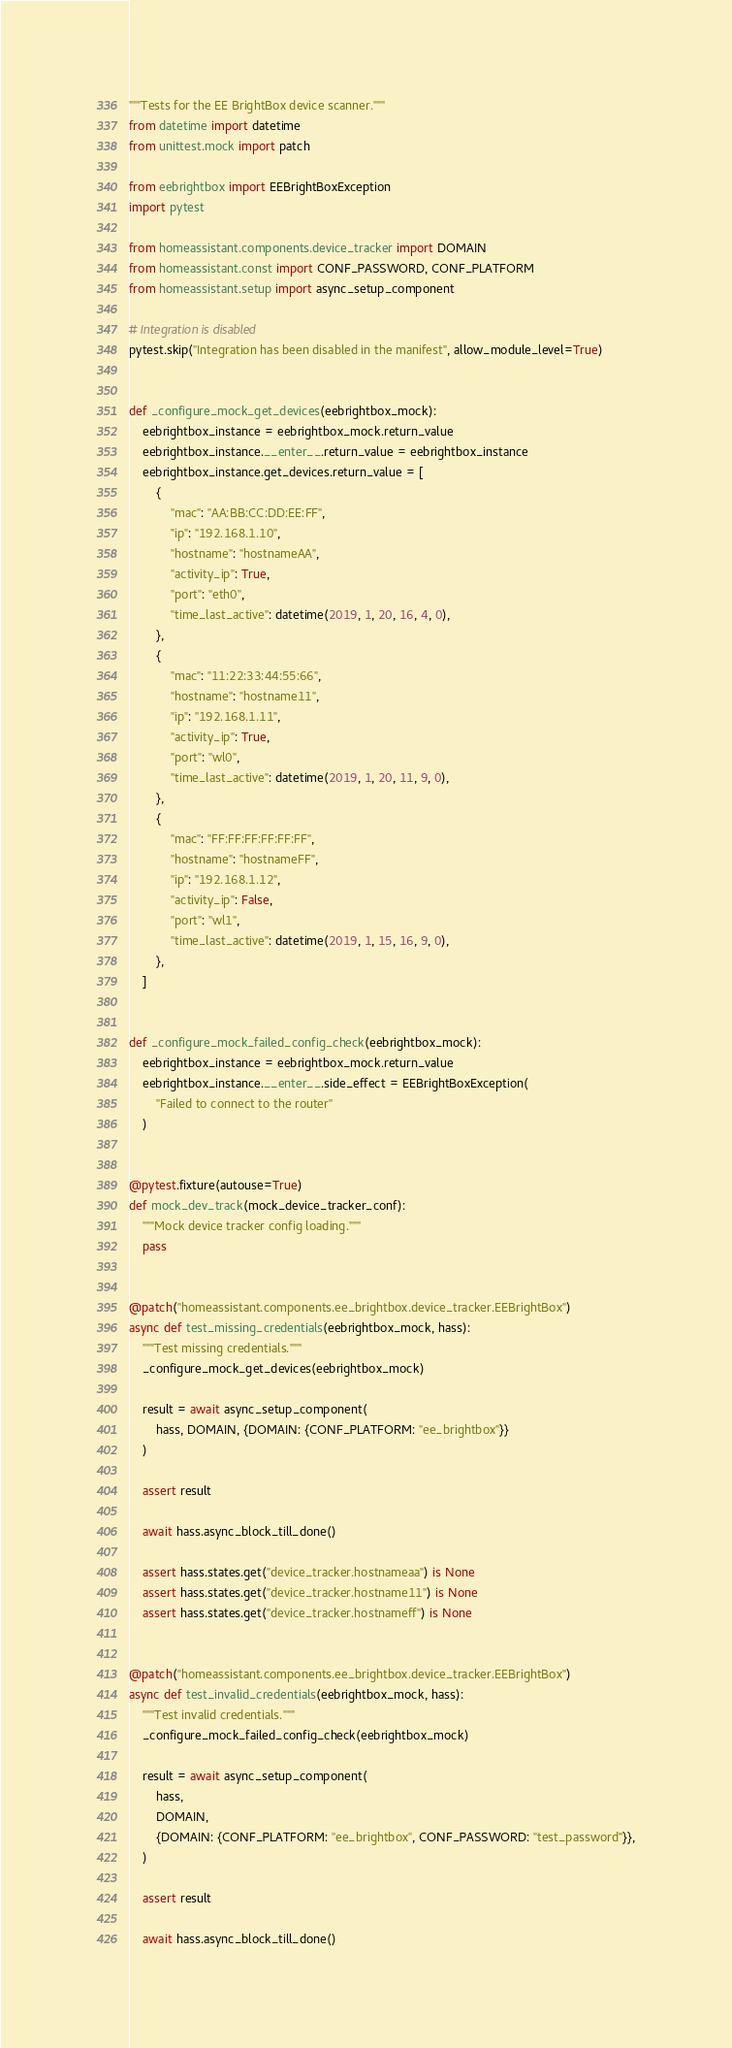Convert code to text. <code><loc_0><loc_0><loc_500><loc_500><_Python_>"""Tests for the EE BrightBox device scanner."""
from datetime import datetime
from unittest.mock import patch

from eebrightbox import EEBrightBoxException
import pytest

from homeassistant.components.device_tracker import DOMAIN
from homeassistant.const import CONF_PASSWORD, CONF_PLATFORM
from homeassistant.setup import async_setup_component

# Integration is disabled
pytest.skip("Integration has been disabled in the manifest", allow_module_level=True)


def _configure_mock_get_devices(eebrightbox_mock):
    eebrightbox_instance = eebrightbox_mock.return_value
    eebrightbox_instance.__enter__.return_value = eebrightbox_instance
    eebrightbox_instance.get_devices.return_value = [
        {
            "mac": "AA:BB:CC:DD:EE:FF",
            "ip": "192.168.1.10",
            "hostname": "hostnameAA",
            "activity_ip": True,
            "port": "eth0",
            "time_last_active": datetime(2019, 1, 20, 16, 4, 0),
        },
        {
            "mac": "11:22:33:44:55:66",
            "hostname": "hostname11",
            "ip": "192.168.1.11",
            "activity_ip": True,
            "port": "wl0",
            "time_last_active": datetime(2019, 1, 20, 11, 9, 0),
        },
        {
            "mac": "FF:FF:FF:FF:FF:FF",
            "hostname": "hostnameFF",
            "ip": "192.168.1.12",
            "activity_ip": False,
            "port": "wl1",
            "time_last_active": datetime(2019, 1, 15, 16, 9, 0),
        },
    ]


def _configure_mock_failed_config_check(eebrightbox_mock):
    eebrightbox_instance = eebrightbox_mock.return_value
    eebrightbox_instance.__enter__.side_effect = EEBrightBoxException(
        "Failed to connect to the router"
    )


@pytest.fixture(autouse=True)
def mock_dev_track(mock_device_tracker_conf):
    """Mock device tracker config loading."""
    pass


@patch("homeassistant.components.ee_brightbox.device_tracker.EEBrightBox")
async def test_missing_credentials(eebrightbox_mock, hass):
    """Test missing credentials."""
    _configure_mock_get_devices(eebrightbox_mock)

    result = await async_setup_component(
        hass, DOMAIN, {DOMAIN: {CONF_PLATFORM: "ee_brightbox"}}
    )

    assert result

    await hass.async_block_till_done()

    assert hass.states.get("device_tracker.hostnameaa") is None
    assert hass.states.get("device_tracker.hostname11") is None
    assert hass.states.get("device_tracker.hostnameff") is None


@patch("homeassistant.components.ee_brightbox.device_tracker.EEBrightBox")
async def test_invalid_credentials(eebrightbox_mock, hass):
    """Test invalid credentials."""
    _configure_mock_failed_config_check(eebrightbox_mock)

    result = await async_setup_component(
        hass,
        DOMAIN,
        {DOMAIN: {CONF_PLATFORM: "ee_brightbox", CONF_PASSWORD: "test_password"}},
    )

    assert result

    await hass.async_block_till_done()
</code> 